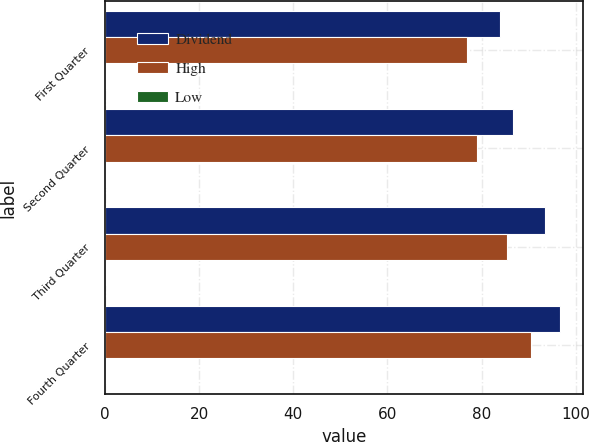Convert chart to OTSL. <chart><loc_0><loc_0><loc_500><loc_500><stacked_bar_chart><ecel><fcel>First Quarter<fcel>Second Quarter<fcel>Third Quarter<fcel>Fourth Quarter<nl><fcel>Dividend<fcel>83.84<fcel>86.77<fcel>93.54<fcel>96.62<nl><fcel>High<fcel>76.98<fcel>79.13<fcel>85.45<fcel>90.47<nl><fcel>Low<fcel>0.29<fcel>0.29<fcel>0.29<fcel>0.29<nl></chart> 